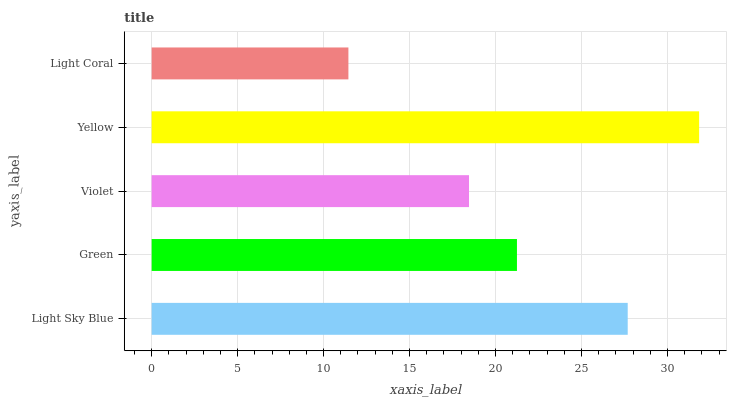Is Light Coral the minimum?
Answer yes or no. Yes. Is Yellow the maximum?
Answer yes or no. Yes. Is Green the minimum?
Answer yes or no. No. Is Green the maximum?
Answer yes or no. No. Is Light Sky Blue greater than Green?
Answer yes or no. Yes. Is Green less than Light Sky Blue?
Answer yes or no. Yes. Is Green greater than Light Sky Blue?
Answer yes or no. No. Is Light Sky Blue less than Green?
Answer yes or no. No. Is Green the high median?
Answer yes or no. Yes. Is Green the low median?
Answer yes or no. Yes. Is Yellow the high median?
Answer yes or no. No. Is Light Sky Blue the low median?
Answer yes or no. No. 